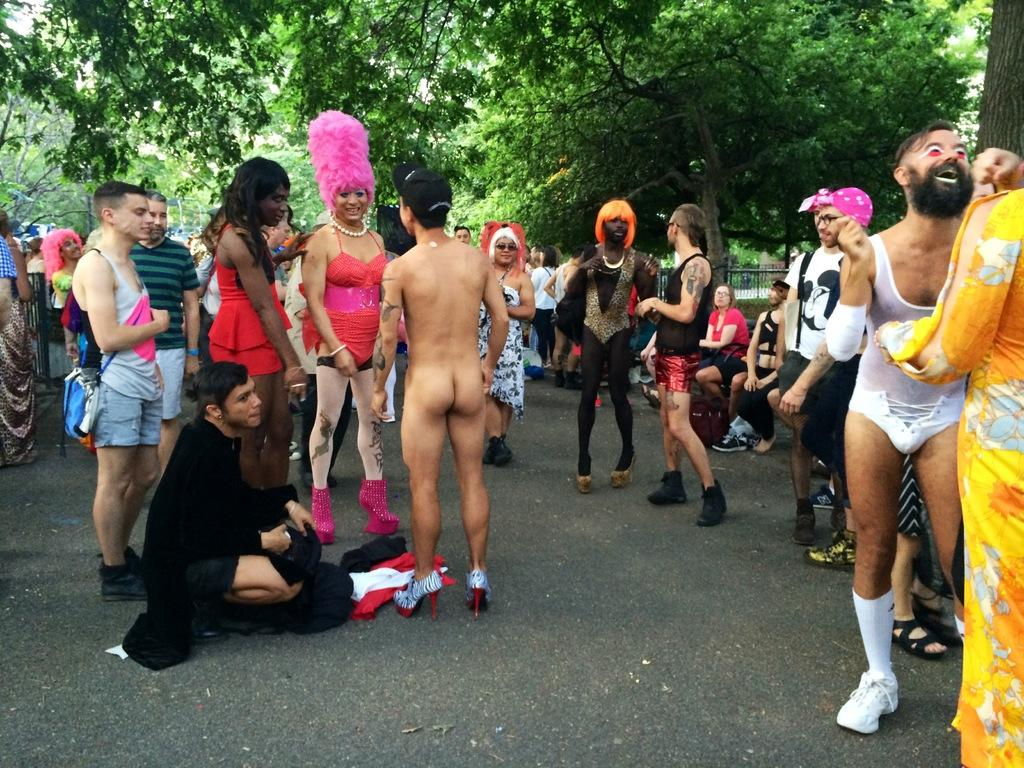What can be seen in the image in terms of human presence? There are groups of people standing in the image. What are the people wearing in the image? The people are wearing fancy dresses. What type of natural elements are present in the image? There are trees with branches and leaves in the image. What type of man-made structure can be seen in the image? There is a road visible in the image. How many stamps are on the pocket of the person in the image? There is no person with a pocket or stamps visible in the image. What is the interest rate of the loan taken by the person in the image? There is no person or loan mentioned in the image. 